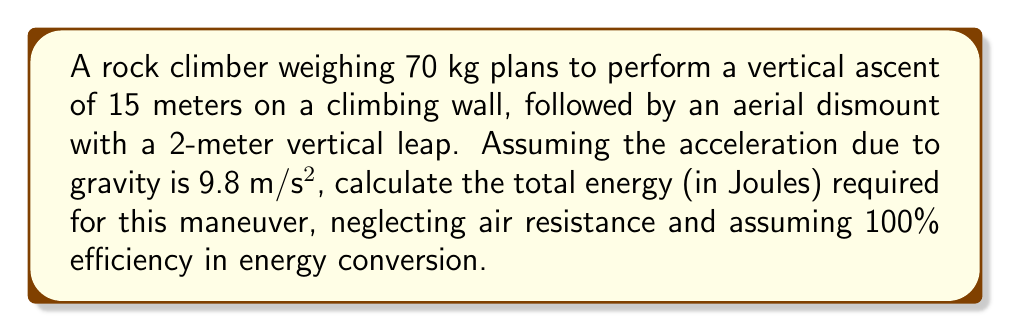Could you help me with this problem? To solve this problem, we need to calculate the energy required for both the vertical ascent and the aerial dismount. We'll use the principle of conservation of energy and the formula for gravitational potential energy.

1. Energy for vertical ascent:
   The gravitational potential energy gained during the ascent is given by:
   $$E_{ascent} = mgh_1$$
   where $m$ is the mass of the climber, $g$ is the acceleration due to gravity, and $h_1$ is the height of the ascent.

   $$E_{ascent} = 70 \text{ kg} \times 9.8 \text{ m/s²} \times 15 \text{ m} = 10,290 \text{ J}$$

2. Energy for aerial dismount:
   The energy required for the vertical leap is the sum of the gravitational potential energy at the peak of the jump and the initial kinetic energy needed to reach that height:
   $$E_{dismount} = mgh_2 + \frac{1}{2}mv^2$$
   where $h_2$ is the height of the leap, and $v$ is the initial velocity needed to reach that height.

   We can find $v$ using the equation:
   $$v = \sqrt{2gh_2}$$

   $$v = \sqrt{2 \times 9.8 \text{ m/s²} \times 2 \text{ m}} = 6.26 \text{ m/s}$$

   Now we can calculate $E_{dismount}$:
   $$E_{dismount} = 70 \text{ kg} \times 9.8 \text{ m/s²} \times 2 \text{ m} + \frac{1}{2} \times 70 \text{ kg} \times (6.26 \text{ m/s})^2$$
   $$E_{dismount} = 1,372 \text{ J} + 1,372 \text{ J} = 2,744 \text{ J}$$

3. Total energy required:
   $$E_{total} = E_{ascent} + E_{dismount}$$
   $$E_{total} = 10,290 \text{ J} + 2,744 \text{ J} = 13,034 \text{ J}$$
Answer: The total energy required for the vertical ascent and aerial dismount is 13,034 J. 